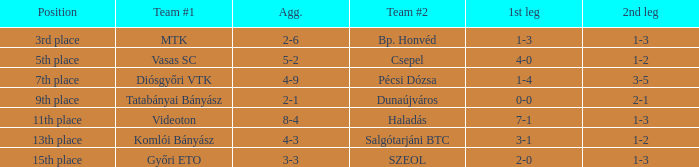What is the 2nd leg of the 4-9 agg.? 3-5. 